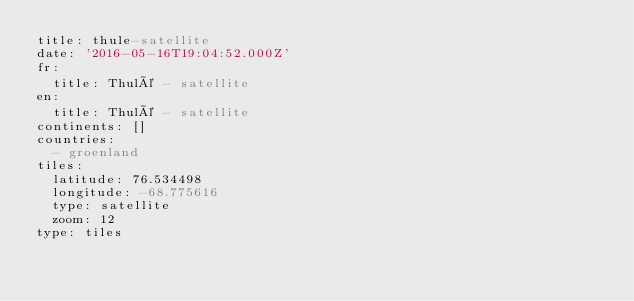<code> <loc_0><loc_0><loc_500><loc_500><_YAML_>title: thule-satellite
date: '2016-05-16T19:04:52.000Z'
fr:
  title: Thulé - satellite
en:
  title: Thulé - satellite
continents: []
countries:
  - groenland
tiles:
  latitude: 76.534498
  longitude: -68.775616
  type: satellite
  zoom: 12
type: tiles
</code> 